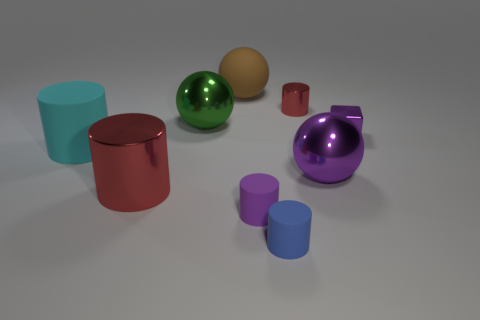Subtract all big green metallic spheres. How many spheres are left? 2 Add 1 big yellow matte cylinders. How many objects exist? 10 Subtract all purple spheres. How many spheres are left? 2 Subtract all cylinders. How many objects are left? 4 Subtract all rubber cylinders. Subtract all big red cylinders. How many objects are left? 5 Add 6 big cylinders. How many big cylinders are left? 8 Add 7 large red metal cubes. How many large red metal cubes exist? 7 Subtract 1 green spheres. How many objects are left? 8 Subtract 1 cylinders. How many cylinders are left? 4 Subtract all yellow cylinders. Subtract all green blocks. How many cylinders are left? 5 